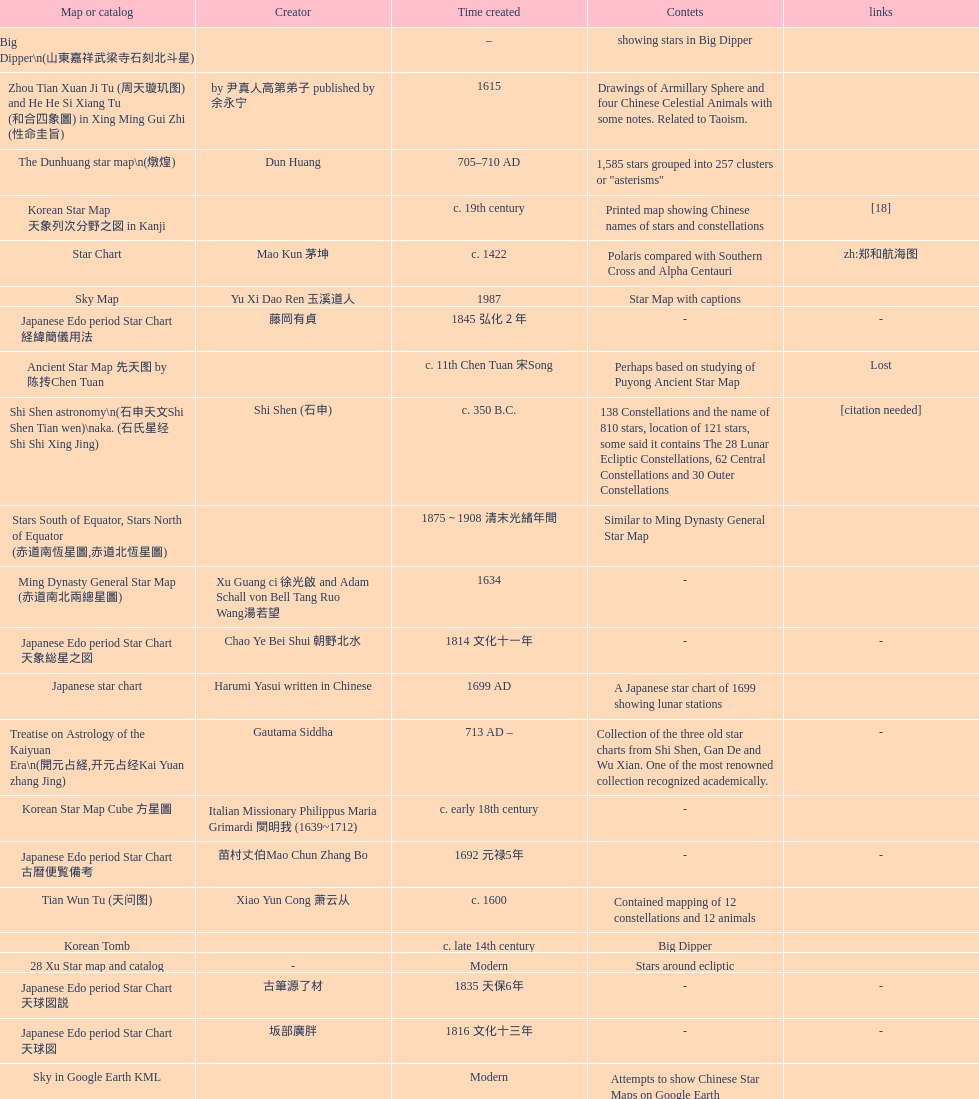Did xu guang ci or su song create the five star charts in 1094 ad? Su Song 蘇頌. 